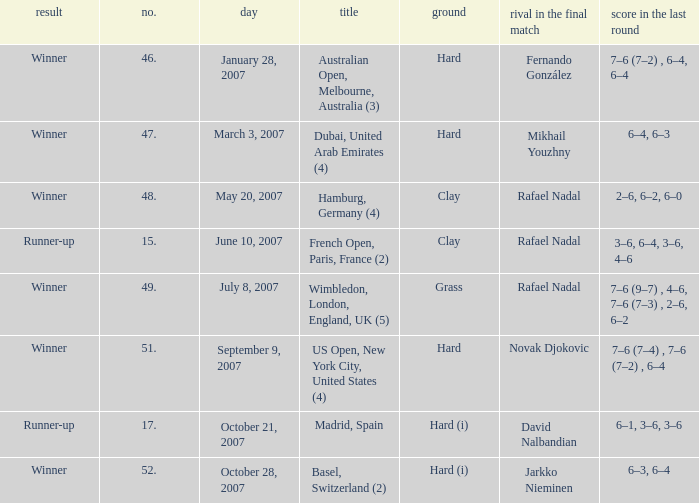Where is the championship where 6–1, 3–6, 3–6 is the score in the final? Madrid, Spain. 